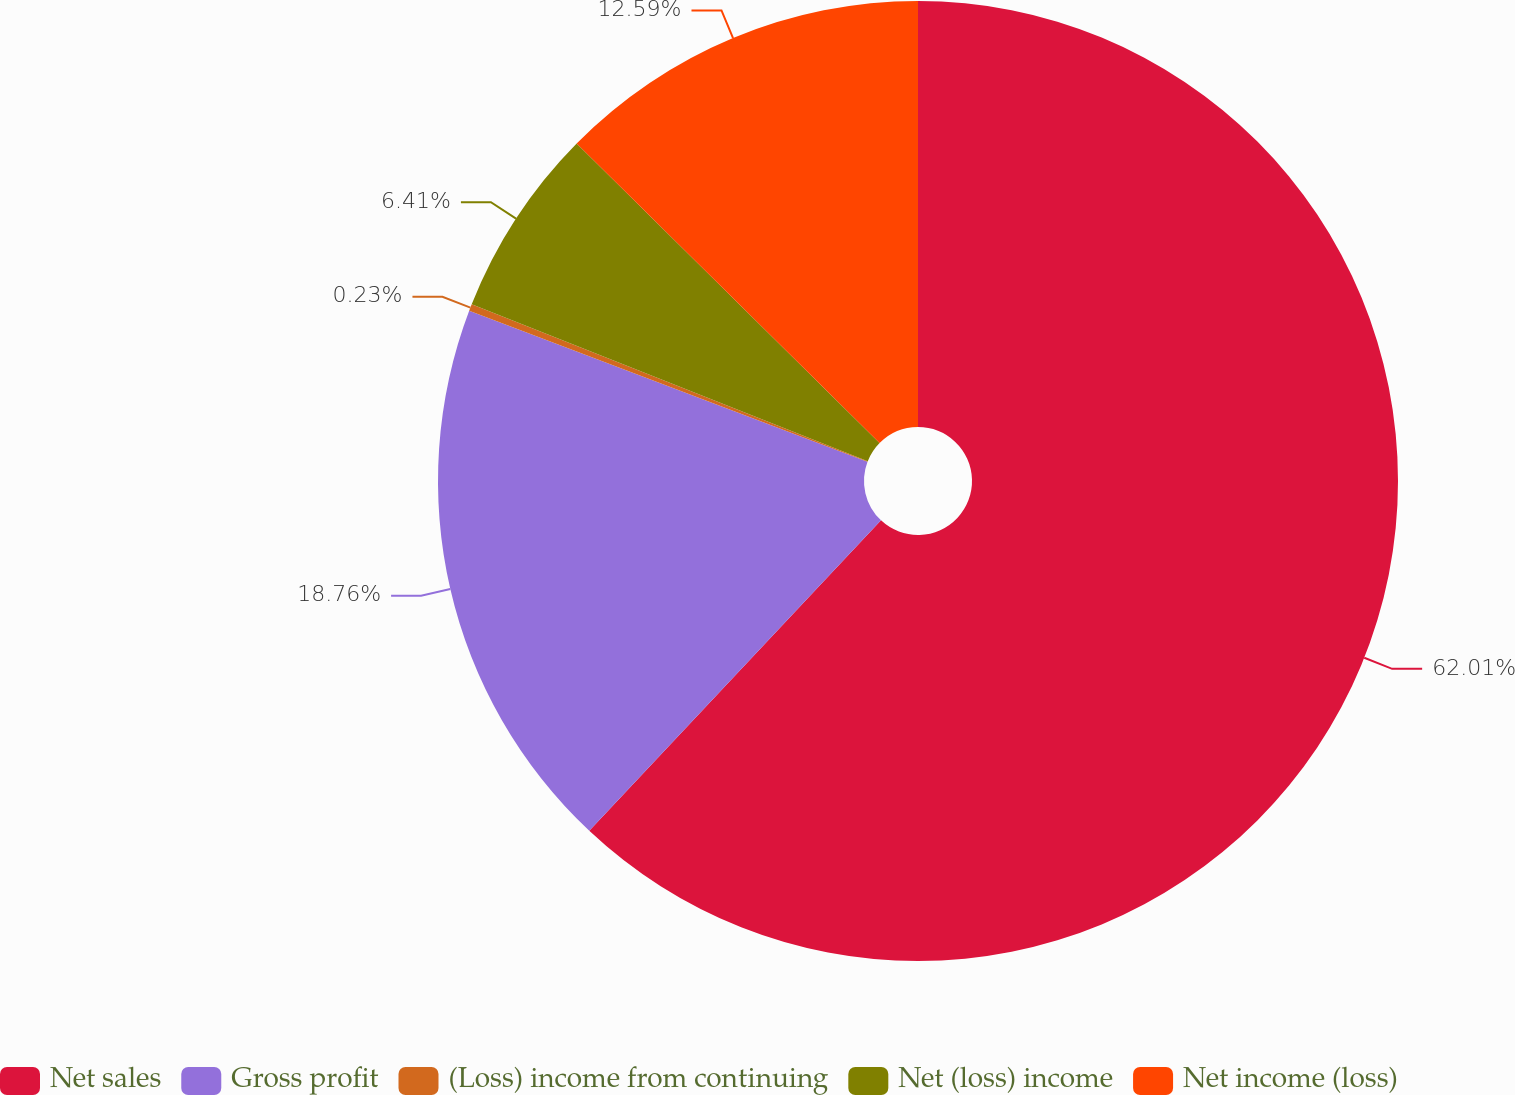<chart> <loc_0><loc_0><loc_500><loc_500><pie_chart><fcel>Net sales<fcel>Gross profit<fcel>(Loss) income from continuing<fcel>Net (loss) income<fcel>Net income (loss)<nl><fcel>62.0%<fcel>18.76%<fcel>0.23%<fcel>6.41%<fcel>12.59%<nl></chart> 